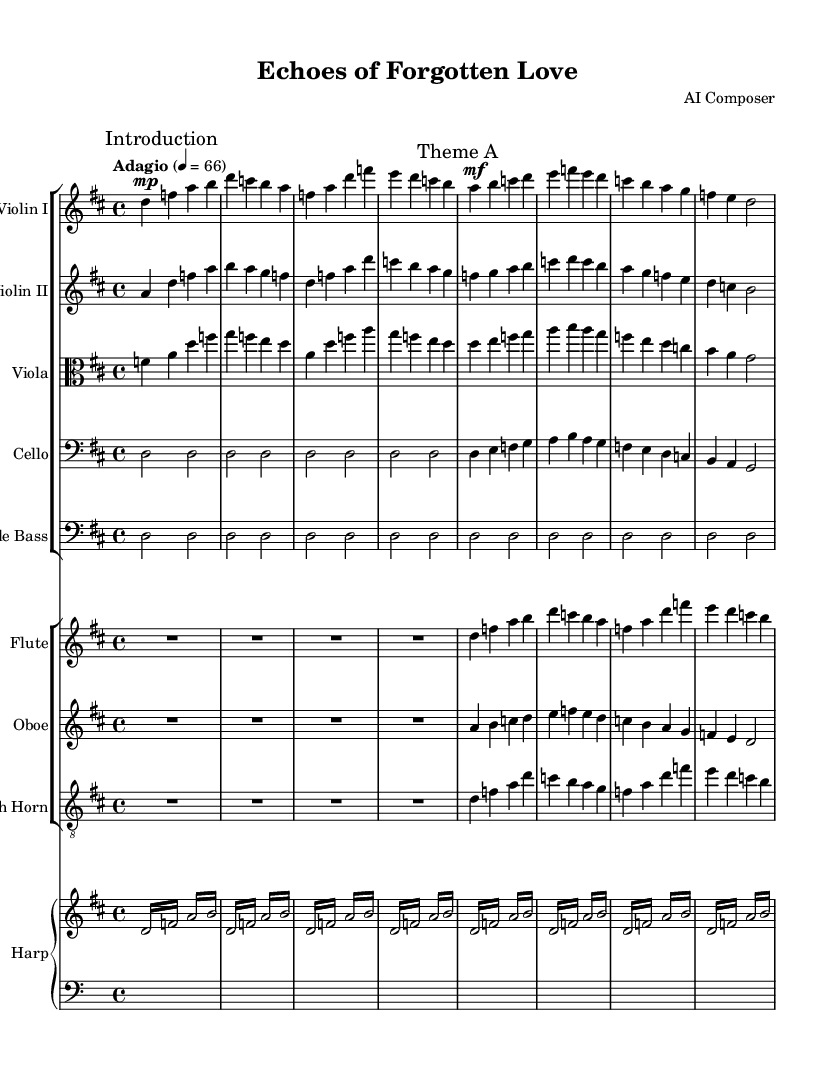What is the key signature of this composition? The key signature is indicated at the beginning of the score, which features two sharps (F# and C#) suggesting that the key is D major.
Answer: D major What is the time signature of the piece? The time signature, located after the key signature, is specified as 4/4, indicating four beats per measure.
Answer: 4/4 What is the tempo marking for this piece? The tempo marking is provided in the first line, indicating the speed of the piece as "Adagio," which typically means slow.
Answer: Adagio How many measures are included in "Theme A"? By counting the measures listed under "Theme A," we find that there are a total of 8 measures present in this section of the composition.
Answer: 8 What instrument plays the highest pitch in the introduction? Reviewing the introduction section, the flute and the first violin have significant high notes; however, the flute generally plays the highest pitch among all instruments during this section.
Answer: Flute Which instrument has a clef that indicates it plays in a lower pitch range? The cello is indicated by the bass clef at the beginning of its staff, signifying that it will play in the lower pitch range compared to the other instruments.
Answer: Cello What is the dynamic marking of the "Theme A" for the first violin? The dynamic marking shows that the first violin should play "mf" (mezzo forte) during "Theme A," indicating a moderately loud volume.
Answer: mf 